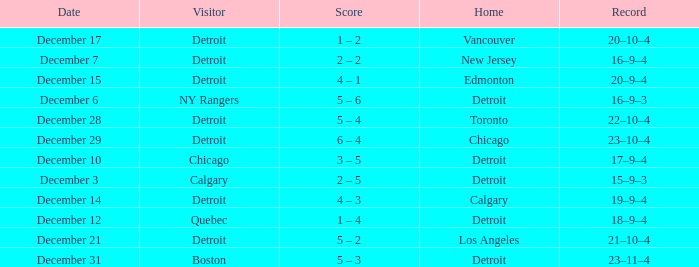Who is the visitor on the date december 31? Boston. 